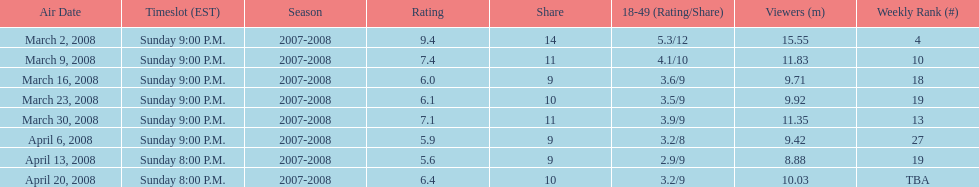How long did the program air for in days? 8. 